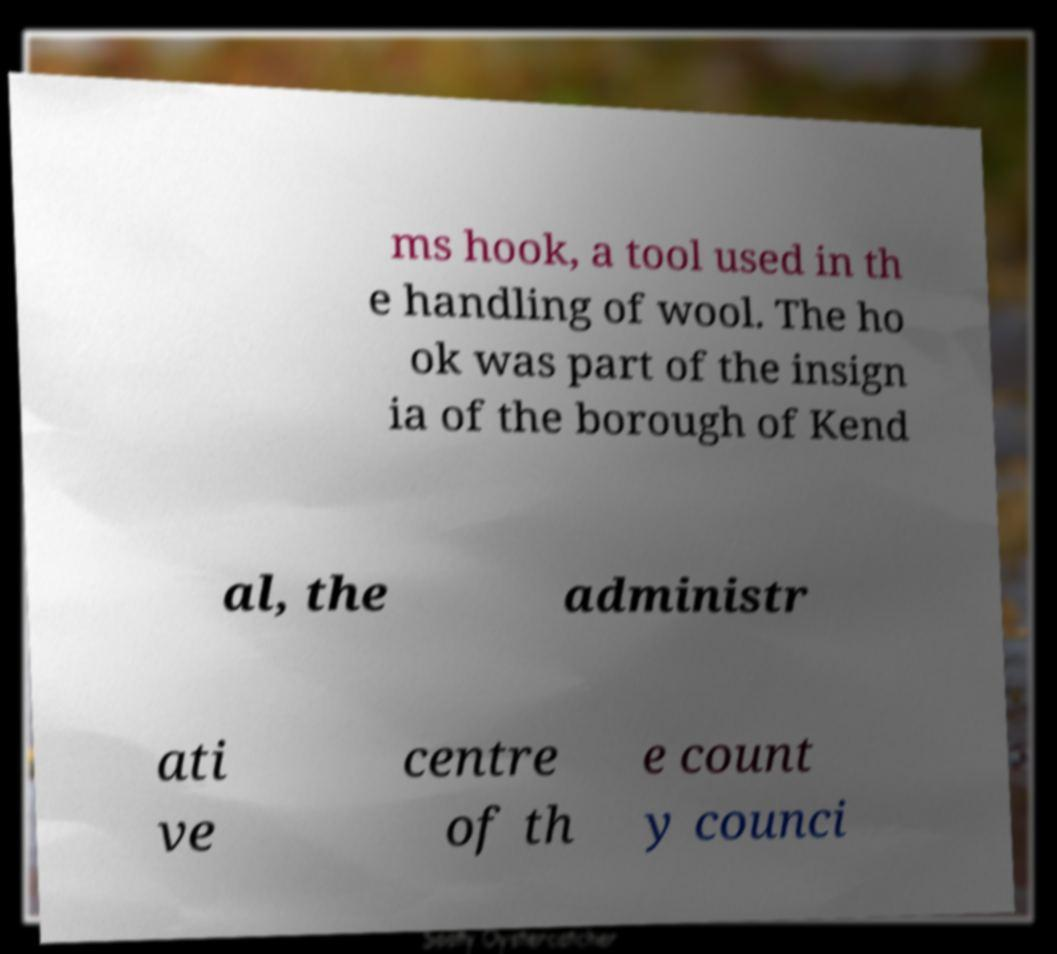Could you extract and type out the text from this image? ms hook, a tool used in th e handling of wool. The ho ok was part of the insign ia of the borough of Kend al, the administr ati ve centre of th e count y counci 